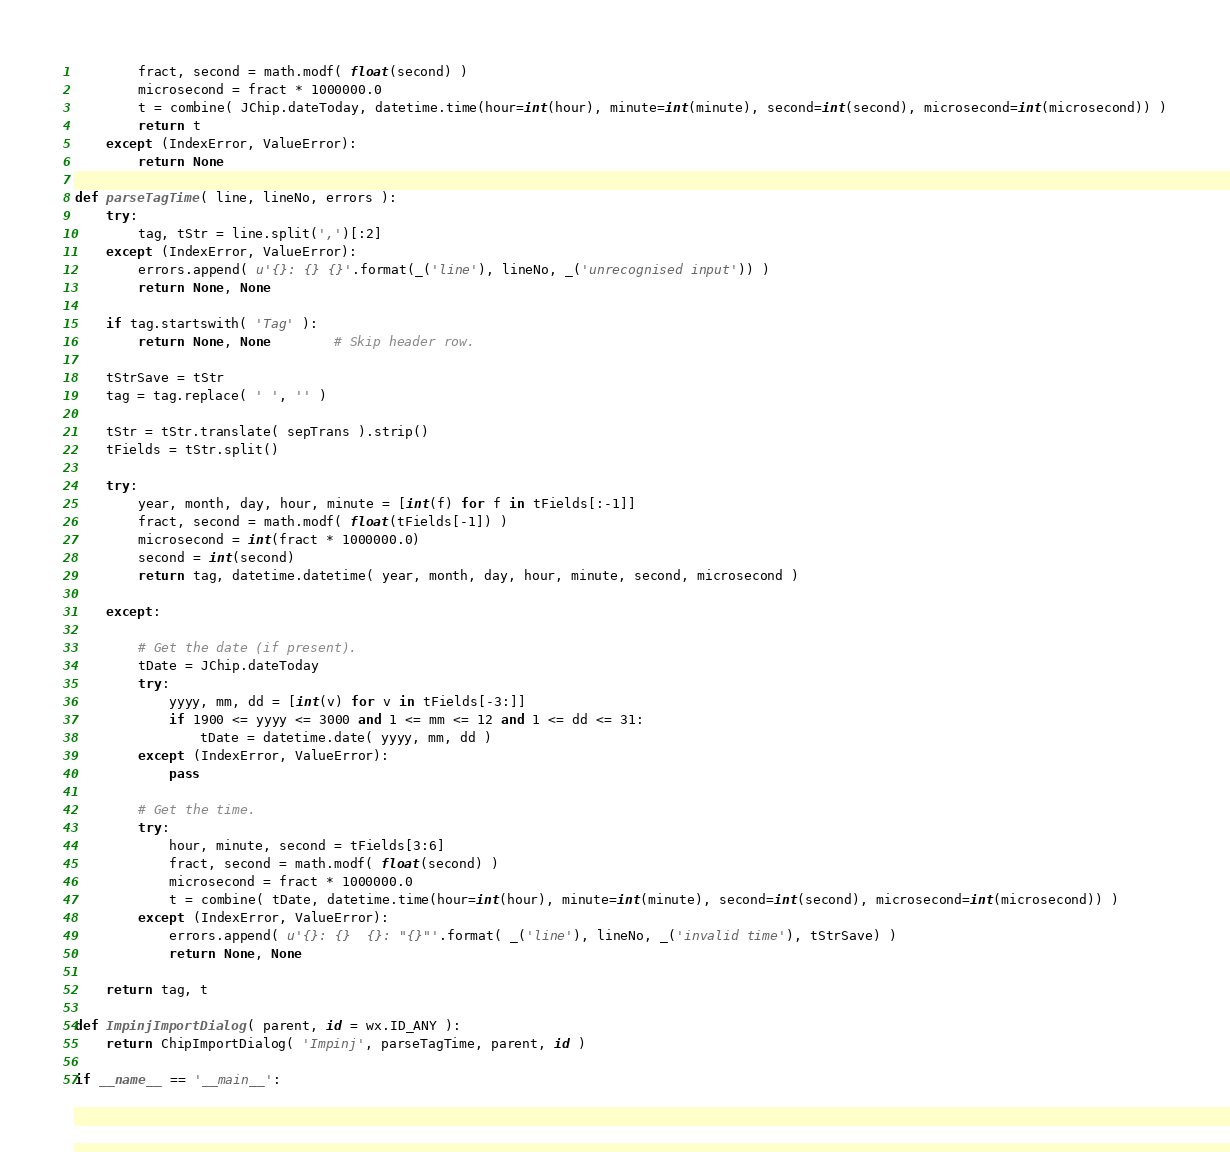<code> <loc_0><loc_0><loc_500><loc_500><_Python_>		fract, second = math.modf( float(second) )
		microsecond = fract * 1000000.0
		t = combine( JChip.dateToday, datetime.time(hour=int(hour), minute=int(minute), second=int(second), microsecond=int(microsecond)) )
		return t
	except (IndexError, ValueError):
		return None

def parseTagTime( line, lineNo, errors ):
	try:
		tag, tStr = line.split(',')[:2]
	except (IndexError, ValueError):
		errors.append( u'{}: {} {}'.format(_('line'), lineNo, _('unrecognised input')) )
		return None, None
	
	if tag.startswith( 'Tag' ):
		return None, None		# Skip header row.
	
	tStrSave = tStr
	tag = tag.replace( ' ', '' )
	
	tStr = tStr.translate( sepTrans ).strip()
	tFields = tStr.split()
	
	try:
		year, month, day, hour, minute = [int(f) for f in tFields[:-1]]
		fract, second = math.modf( float(tFields[-1]) )
		microsecond = int(fract * 1000000.0)
		second = int(second)
		return tag, datetime.datetime( year, month, day, hour, minute, second, microsecond )
	
	except:
	
		# Get the date (if present).
		tDate = JChip.dateToday
		try:
			yyyy, mm, dd = [int(v) for v in tFields[-3:]]
			if 1900 <= yyyy <= 3000 and 1 <= mm <= 12 and 1 <= dd <= 31:
				tDate = datetime.date( yyyy, mm, dd )
		except (IndexError, ValueError):
			pass
		
		# Get the time.
		try:
			hour, minute, second = tFields[3:6]
			fract, second = math.modf( float(second) )
			microsecond = fract * 1000000.0
			t = combine( tDate, datetime.time(hour=int(hour), minute=int(minute), second=int(second), microsecond=int(microsecond)) )
		except (IndexError, ValueError):
			errors.append( u'{}: {}  {}: "{}"'.format( _('line'), lineNo, _('invalid time'), tStrSave) )
			return None, None
	
	return tag, t

def ImpinjImportDialog( parent, id = wx.ID_ANY ):
	return ChipImportDialog( 'Impinj', parseTagTime, parent, id )
		
if __name__ == '__main__':</code> 